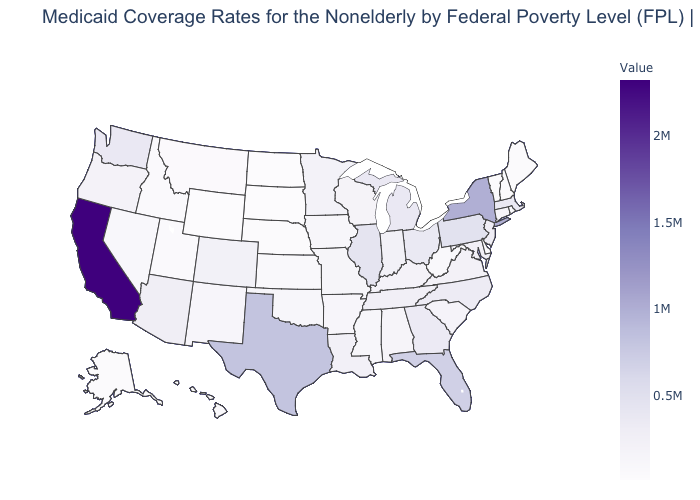Which states have the lowest value in the USA?
Write a very short answer. North Dakota. Does the map have missing data?
Give a very brief answer. No. Which states have the lowest value in the USA?
Keep it brief. North Dakota. Among the states that border Kentucky , which have the highest value?
Keep it brief. Illinois. Which states have the highest value in the USA?
Keep it brief. California. Does North Dakota have the lowest value in the USA?
Quick response, please. Yes. Does Nevada have the highest value in the West?
Concise answer only. No. Among the states that border Colorado , does Wyoming have the lowest value?
Answer briefly. Yes. Does the map have missing data?
Be succinct. No. 